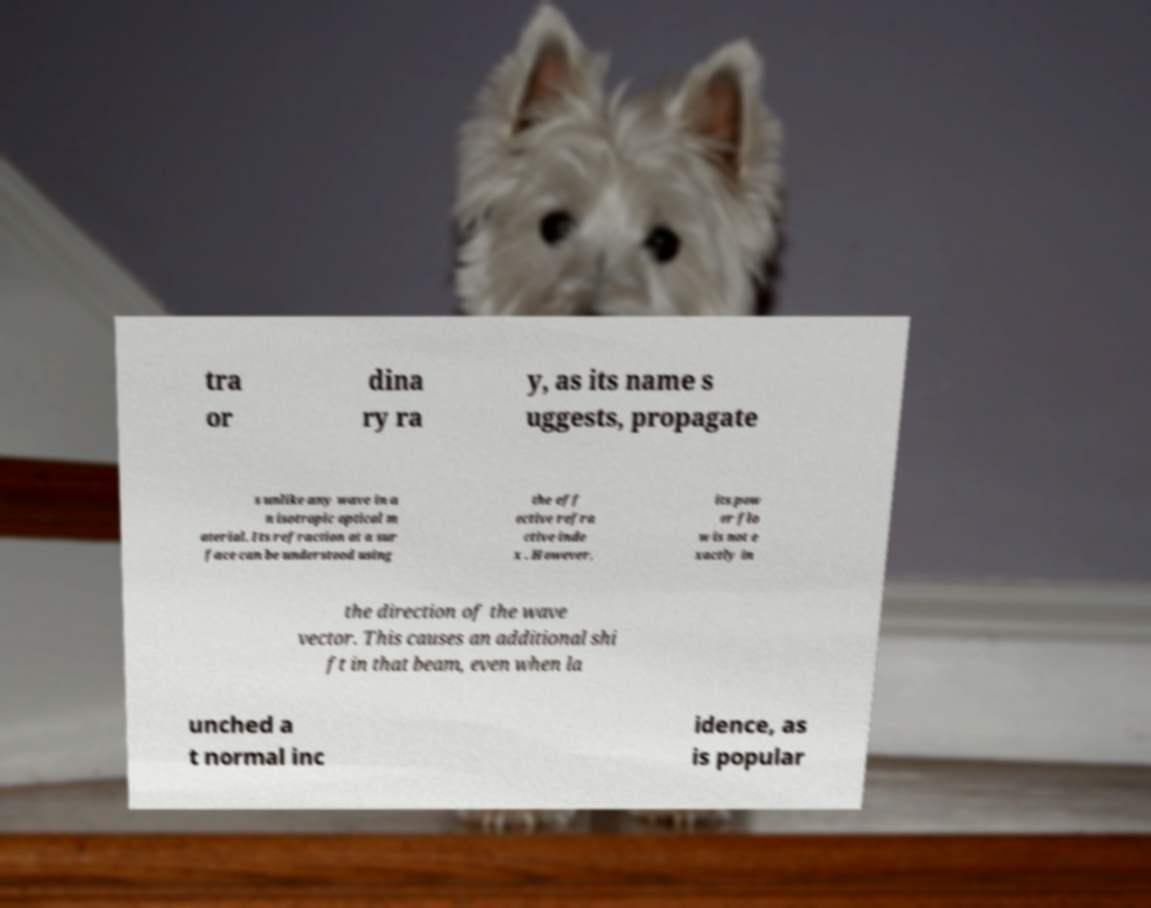There's text embedded in this image that I need extracted. Can you transcribe it verbatim? tra or dina ry ra y, as its name s uggests, propagate s unlike any wave in a n isotropic optical m aterial. Its refraction at a sur face can be understood using the eff ective refra ctive inde x . However, its pow er flo w is not e xactly in the direction of the wave vector. This causes an additional shi ft in that beam, even when la unched a t normal inc idence, as is popular 